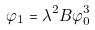<formula> <loc_0><loc_0><loc_500><loc_500>\varphi _ { 1 } = \lambda ^ { 2 } B \varphi _ { 0 } ^ { 3 }</formula> 